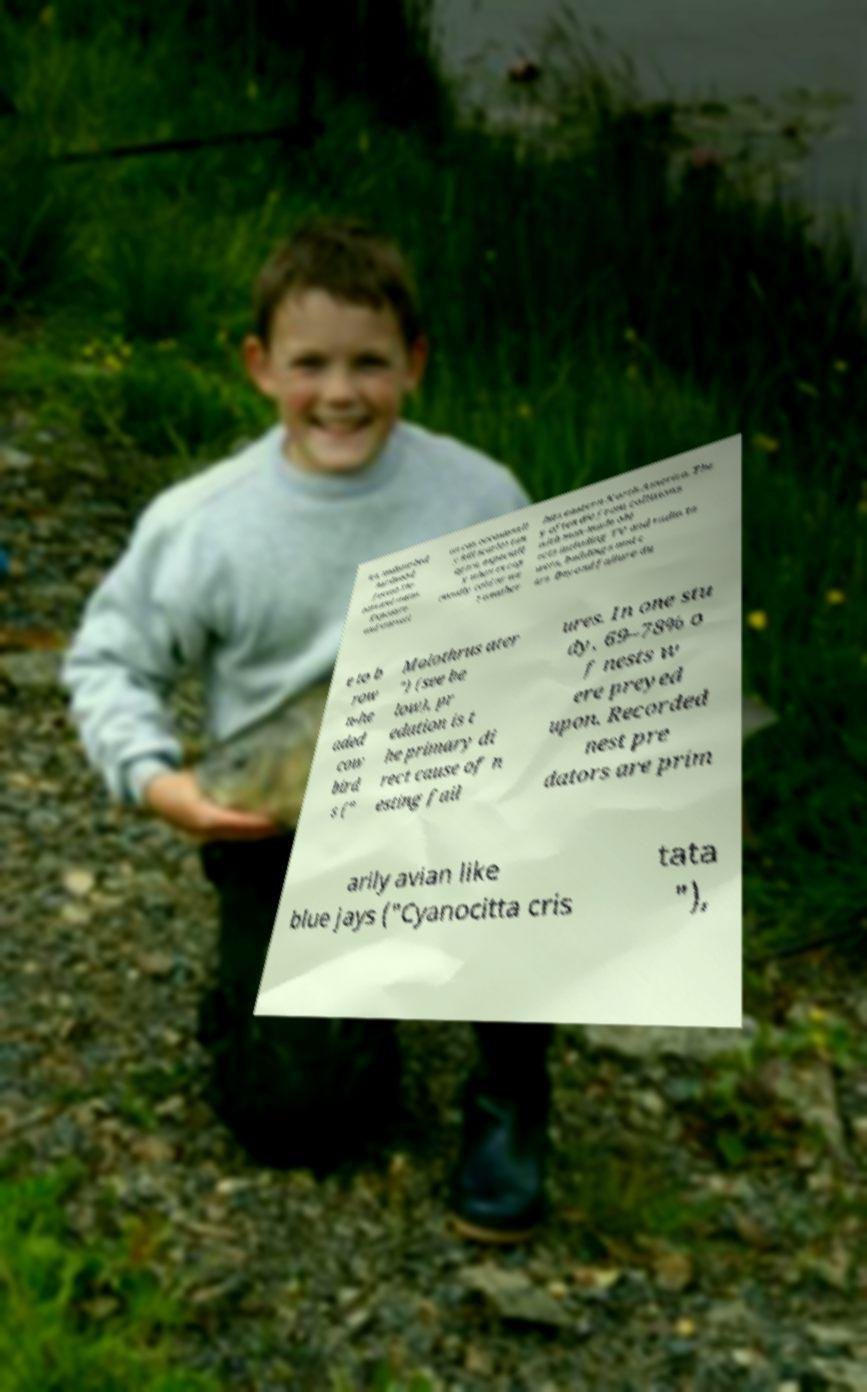Could you extract and type out the text from this image? ive, undisturbed hardwood forest.Thr eats and status. Exposure and starvati on can occasionall y kill scarlet tan agers, especiall y when excep tionally cold or we t weather hits eastern North America. The y often die from collisions with man-made obj ects including TV and radio to wers, buildings and c ars. Beyond failure du e to b row n-he aded cow bird s (" Molothrus ater ") (see be low), pr edation is t he primary di rect cause of n esting fail ures. In one stu dy, 69–78% o f nests w ere preyed upon. Recorded nest pre dators are prim arily avian like blue jays ("Cyanocitta cris tata "), 